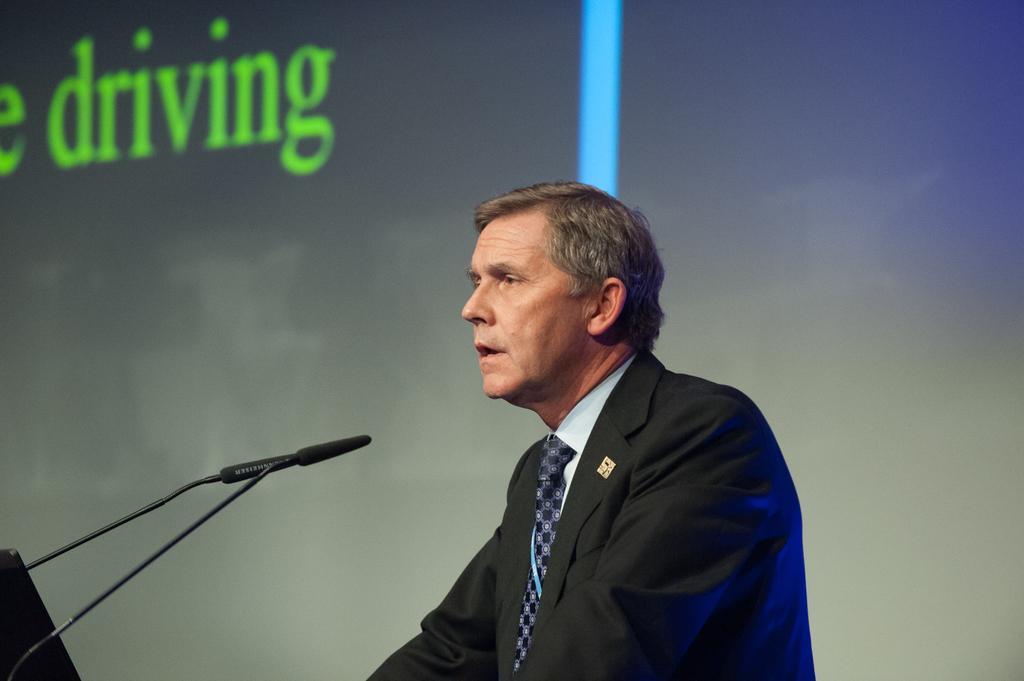In one or two sentences, can you explain what this image depicts? In this image we can see the person standing in front of the mic and at the back it looks like a screen with text. 